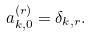Convert formula to latex. <formula><loc_0><loc_0><loc_500><loc_500>a _ { k , 0 } ^ { ( r ) } = \delta _ { k , r } .</formula> 